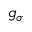Convert formula to latex. <formula><loc_0><loc_0><loc_500><loc_500>g _ { \sigma }</formula> 